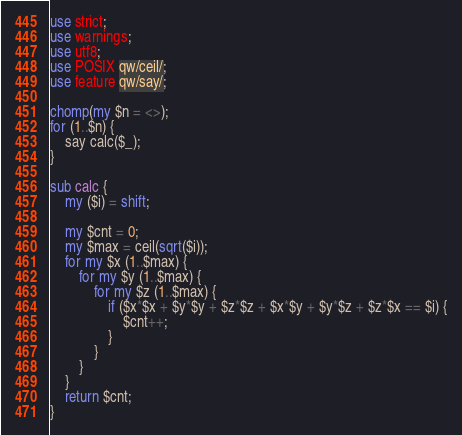<code> <loc_0><loc_0><loc_500><loc_500><_Perl_>use strict;
use warnings;
use utf8;
use POSIX qw/ceil/;
use feature qw/say/;

chomp(my $n = <>);
for (1..$n) {
    say calc($_);
}

sub calc {
    my ($i) = shift;

    my $cnt = 0;
    my $max = ceil(sqrt($i));
    for my $x (1..$max) {
        for my $y (1..$max) {
            for my $z (1..$max) {
                if ($x*$x + $y*$y + $z*$z + $x*$y + $y*$z + $z*$x == $i) {
                    $cnt++;
                }
            }
        }
    }
    return $cnt;
}
</code> 